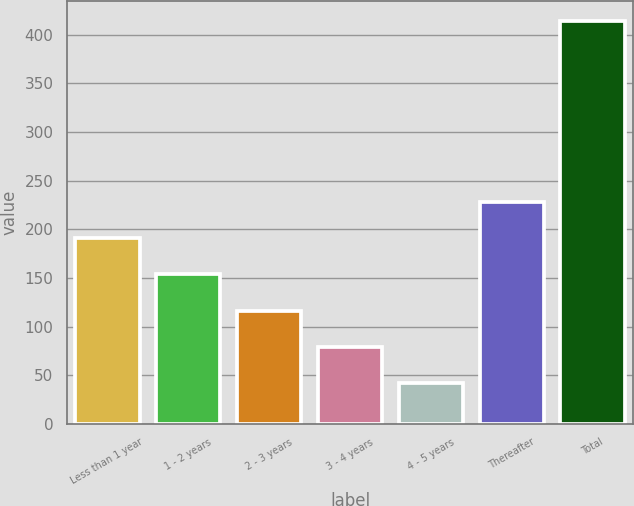Convert chart. <chart><loc_0><loc_0><loc_500><loc_500><bar_chart><fcel>Less than 1 year<fcel>1 - 2 years<fcel>2 - 3 years<fcel>3 - 4 years<fcel>4 - 5 years<fcel>Thereafter<fcel>Total<nl><fcel>190.8<fcel>153.6<fcel>116.4<fcel>79.2<fcel>42<fcel>228<fcel>414<nl></chart> 